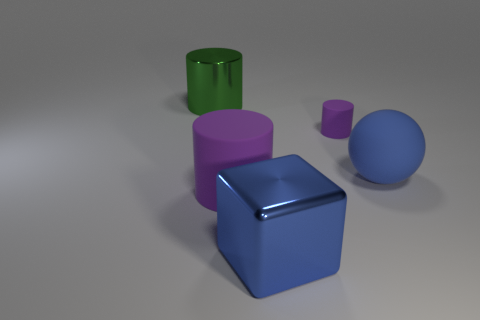Is the sphere the same color as the metal block?
Provide a succinct answer. Yes. There is a large thing that is both on the left side of the tiny purple cylinder and right of the big purple cylinder; what is its material?
Your response must be concise. Metal. What number of other large matte objects are the same shape as the green thing?
Provide a short and direct response. 1. There is a blue cube in front of the blue thing that is behind the blue object that is left of the tiny purple matte object; how big is it?
Your answer should be compact. Large. Is the number of blocks behind the big blue metal thing greater than the number of big metal blocks?
Keep it short and to the point. No. Are there any tiny cylinders?
Ensure brevity in your answer.  Yes. How many blue metallic cubes are the same size as the green metallic cylinder?
Your answer should be very brief. 1. Is the number of blue objects that are behind the blue block greater than the number of big shiny cubes to the right of the large rubber ball?
Offer a terse response. Yes. What material is the ball that is the same size as the blue metal cube?
Keep it short and to the point. Rubber. There is a green metal thing; what shape is it?
Keep it short and to the point. Cylinder. 